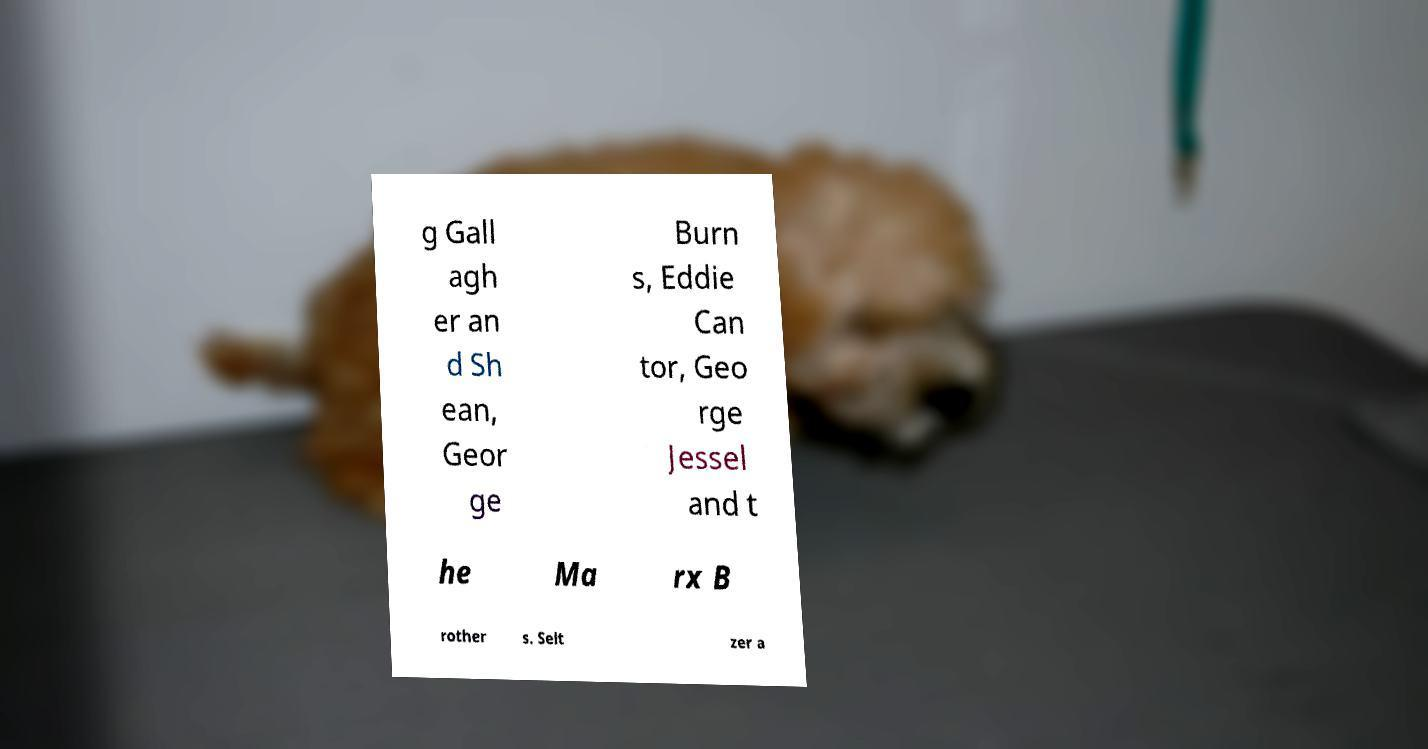Please read and relay the text visible in this image. What does it say? g Gall agh er an d Sh ean, Geor ge Burn s, Eddie Can tor, Geo rge Jessel and t he Ma rx B rother s. Selt zer a 